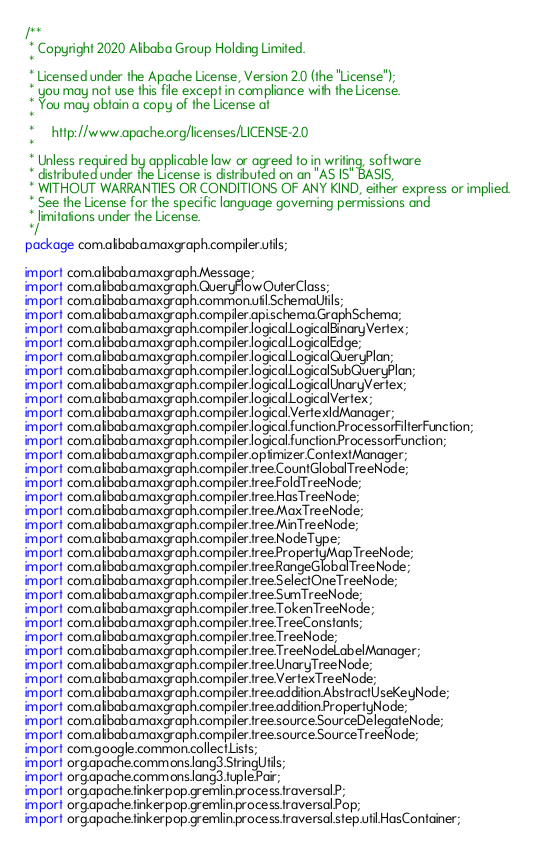<code> <loc_0><loc_0><loc_500><loc_500><_Java_>/**
 * Copyright 2020 Alibaba Group Holding Limited.
 * 
 * Licensed under the Apache License, Version 2.0 (the "License");
 * you may not use this file except in compliance with the License.
 * You may obtain a copy of the License at
 * 
 *     http://www.apache.org/licenses/LICENSE-2.0
 * 
 * Unless required by applicable law or agreed to in writing, software
 * distributed under the License is distributed on an "AS IS" BASIS,
 * WITHOUT WARRANTIES OR CONDITIONS OF ANY KIND, either express or implied.
 * See the License for the specific language governing permissions and
 * limitations under the License.
 */
package com.alibaba.maxgraph.compiler.utils;

import com.alibaba.maxgraph.Message;
import com.alibaba.maxgraph.QueryFlowOuterClass;
import com.alibaba.maxgraph.common.util.SchemaUtils;
import com.alibaba.maxgraph.compiler.api.schema.GraphSchema;
import com.alibaba.maxgraph.compiler.logical.LogicalBinaryVertex;
import com.alibaba.maxgraph.compiler.logical.LogicalEdge;
import com.alibaba.maxgraph.compiler.logical.LogicalQueryPlan;
import com.alibaba.maxgraph.compiler.logical.LogicalSubQueryPlan;
import com.alibaba.maxgraph.compiler.logical.LogicalUnaryVertex;
import com.alibaba.maxgraph.compiler.logical.LogicalVertex;
import com.alibaba.maxgraph.compiler.logical.VertexIdManager;
import com.alibaba.maxgraph.compiler.logical.function.ProcessorFilterFunction;
import com.alibaba.maxgraph.compiler.logical.function.ProcessorFunction;
import com.alibaba.maxgraph.compiler.optimizer.ContextManager;
import com.alibaba.maxgraph.compiler.tree.CountGlobalTreeNode;
import com.alibaba.maxgraph.compiler.tree.FoldTreeNode;
import com.alibaba.maxgraph.compiler.tree.HasTreeNode;
import com.alibaba.maxgraph.compiler.tree.MaxTreeNode;
import com.alibaba.maxgraph.compiler.tree.MinTreeNode;
import com.alibaba.maxgraph.compiler.tree.NodeType;
import com.alibaba.maxgraph.compiler.tree.PropertyMapTreeNode;
import com.alibaba.maxgraph.compiler.tree.RangeGlobalTreeNode;
import com.alibaba.maxgraph.compiler.tree.SelectOneTreeNode;
import com.alibaba.maxgraph.compiler.tree.SumTreeNode;
import com.alibaba.maxgraph.compiler.tree.TokenTreeNode;
import com.alibaba.maxgraph.compiler.tree.TreeConstants;
import com.alibaba.maxgraph.compiler.tree.TreeNode;
import com.alibaba.maxgraph.compiler.tree.TreeNodeLabelManager;
import com.alibaba.maxgraph.compiler.tree.UnaryTreeNode;
import com.alibaba.maxgraph.compiler.tree.VertexTreeNode;
import com.alibaba.maxgraph.compiler.tree.addition.AbstractUseKeyNode;
import com.alibaba.maxgraph.compiler.tree.addition.PropertyNode;
import com.alibaba.maxgraph.compiler.tree.source.SourceDelegateNode;
import com.alibaba.maxgraph.compiler.tree.source.SourceTreeNode;
import com.google.common.collect.Lists;
import org.apache.commons.lang3.StringUtils;
import org.apache.commons.lang3.tuple.Pair;
import org.apache.tinkerpop.gremlin.process.traversal.P;
import org.apache.tinkerpop.gremlin.process.traversal.Pop;
import org.apache.tinkerpop.gremlin.process.traversal.step.util.HasContainer;</code> 